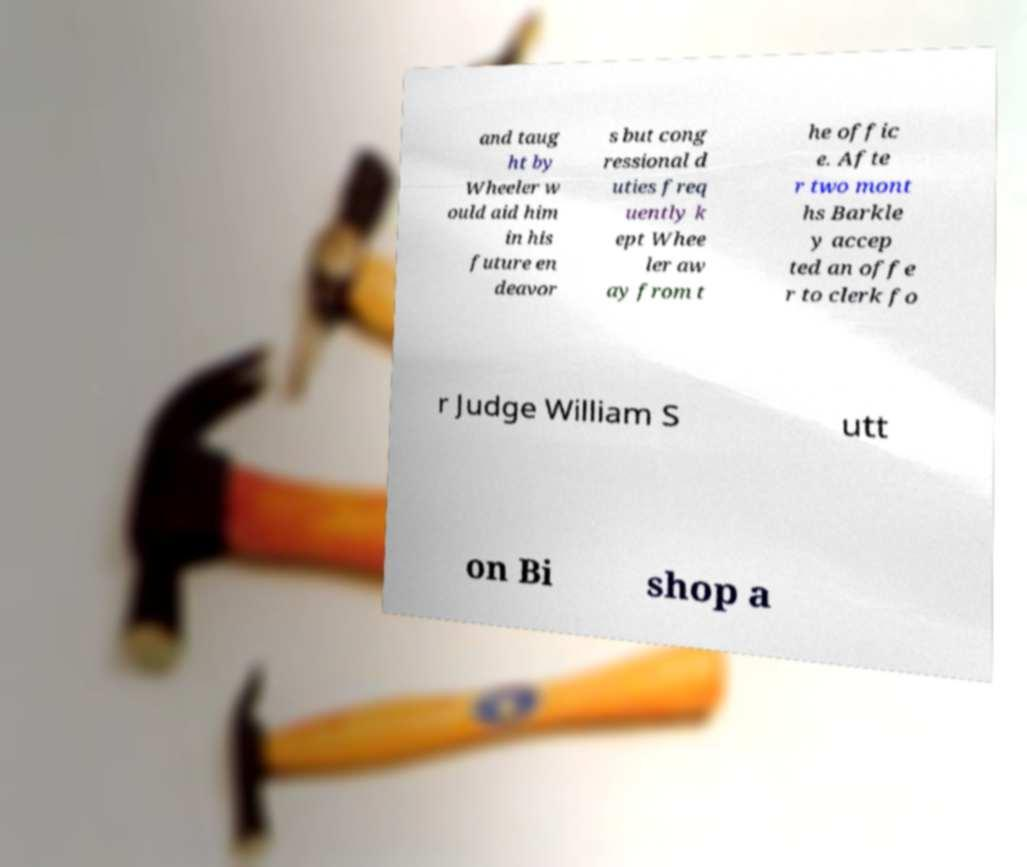I need the written content from this picture converted into text. Can you do that? and taug ht by Wheeler w ould aid him in his future en deavor s but cong ressional d uties freq uently k ept Whee ler aw ay from t he offic e. Afte r two mont hs Barkle y accep ted an offe r to clerk fo r Judge William S utt on Bi shop a 